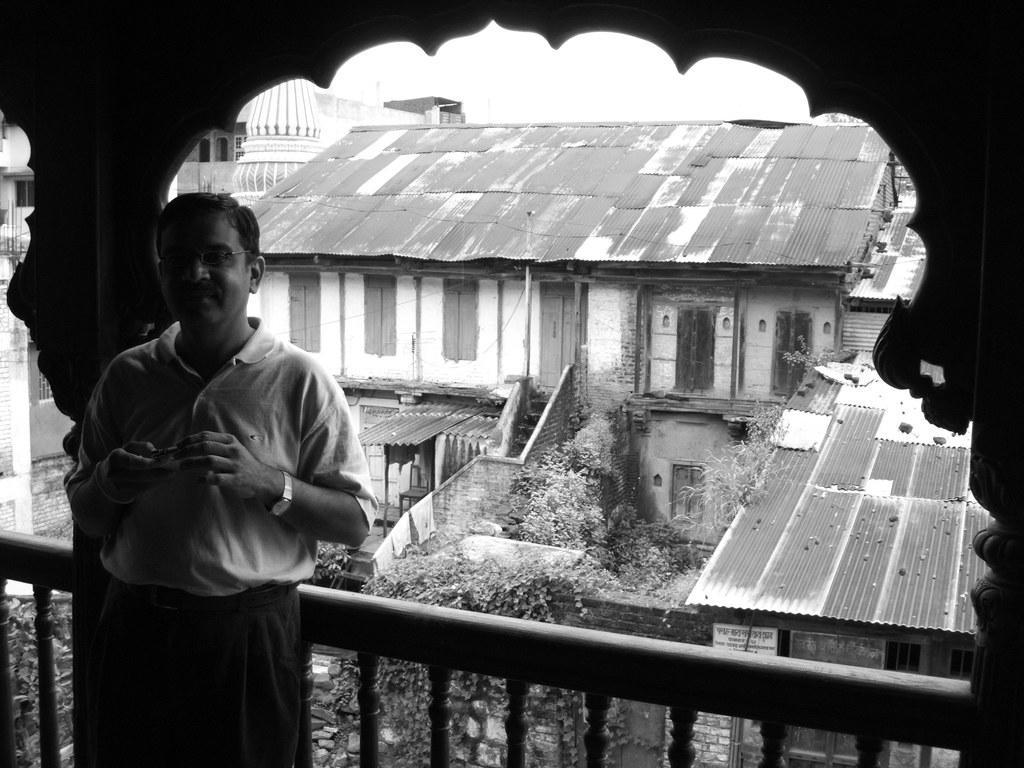Describe this image in one or two sentences. This is a black and white picture. In the foreground of the picture there is a person standing, near a railing. In the center of the picture there are plants, trees and buildings. In the background there are buildings. Sky is cloudy. 